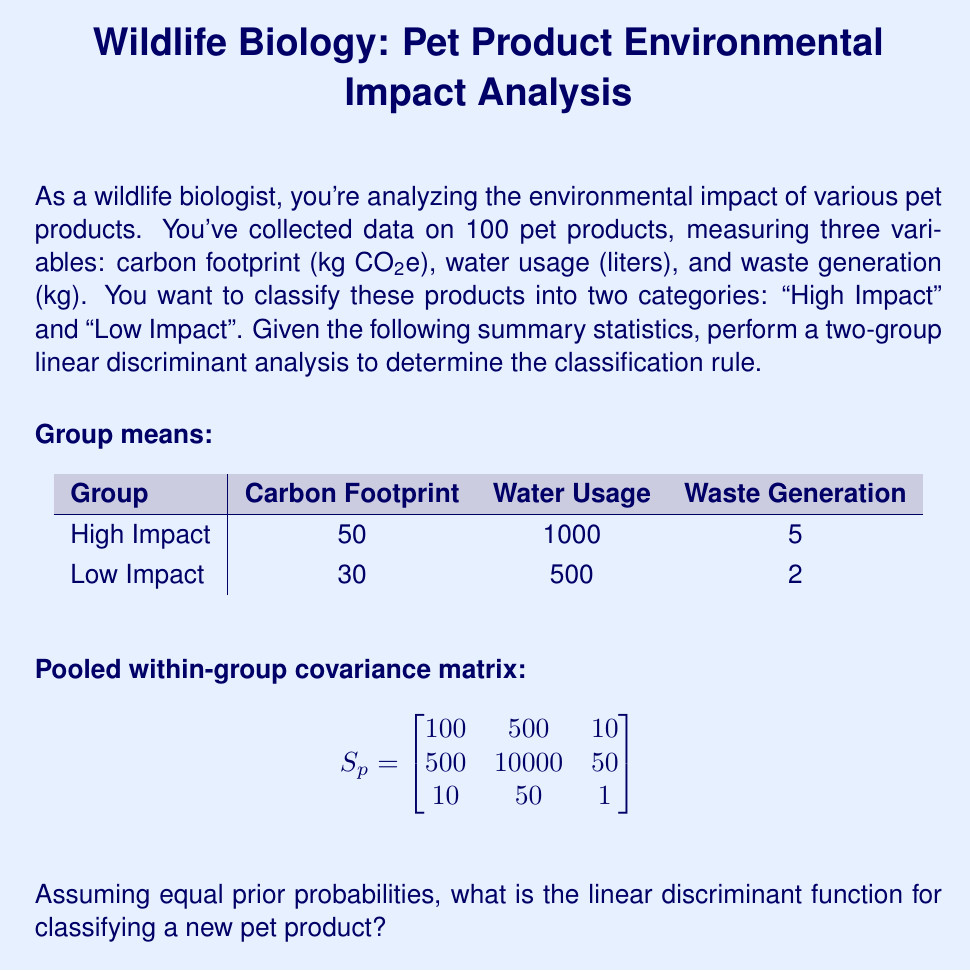What is the answer to this math problem? To perform linear discriminant analysis and determine the classification rule, we'll follow these steps:

1) Calculate the difference between group means:
   $$\bar{x}_1 - \bar{x}_2 = [50 - 30, 1000 - 500, 5 - 2] = [20, 500, 3]$$

2) Calculate the inverse of the pooled within-group covariance matrix:
   $$S_p^{-1} = \begin{bmatrix}
   0.0105 & -0.0005 & -0.0950 \\
   -0.0005 & 0.0001 & 0.0045 \\
   -0.0950 & 0.0045 & 1.0450
   \end{bmatrix}$$

3) The linear discriminant function is given by:
   $$L(x) = (\bar{x}_1 - \bar{x}_2)' S_p^{-1} (x - \frac{\bar{x}_1 + \bar{x}_2}{2})$$

4) Multiply $(\bar{x}_1 - \bar{x}_2)' S_p^{-1}$:
   $$[20, 500, 3] \begin{bmatrix}
   0.0105 & -0.0005 & -0.0950 \\
   -0.0005 & 0.0001 & 0.0045 \\
   -0.0950 & 0.0045 & 1.0450
   \end{bmatrix} = [0.1350, 0.0635, 2.8900]$$

5) Calculate $\frac{\bar{x}_1 + \bar{x}_2}{2}$:
   $$\frac{1}{2}([50, 1000, 5] + [30, 500, 2]) = [40, 750, 3.5]$$

6) The linear discriminant function is:
   $$L(x) = 0.1350(x_1 - 40) + 0.0635(x_2 - 750) + 2.8900(x_3 - 3.5)$$

   Where $x_1$ is carbon footprint, $x_2$ is water usage, and $x_3$ is waste generation.

7) The classification rule is:
   - If $L(x) > 0$, classify as "High Impact"
   - If $L(x) < 0$, classify as "Low Impact"
   - If $L(x) = 0$, the product is on the decision boundary
Answer: $L(x) = 0.1350(x_1 - 40) + 0.0635(x_2 - 750) + 2.8900(x_3 - 3.5)$ 